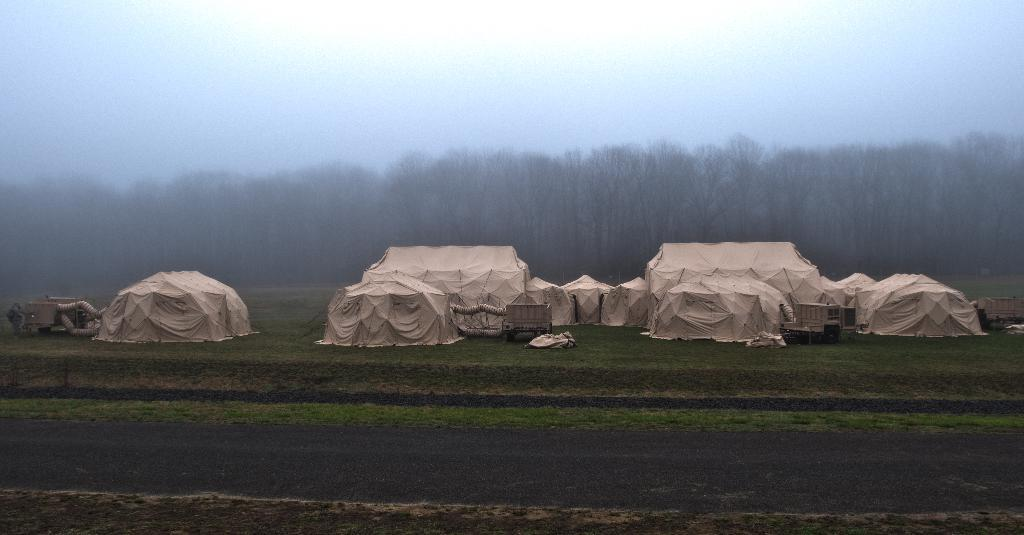What structures are located in the center of the image? There are tents in the center of the image. What type of natural environment is visible in the background of the image? There are trees in the background of the image. What is visible in the sky in the background of the image? The sky is visible in the background of the image. What type of man-made structure can be seen at the bottom of the image? There is a road at the bottom of the image. How many hands are visible in the image? There are no hands visible in the image. What type of work is being done in the image? There is no work being done in the image; it appears to be a campsite or outdoor setting. 